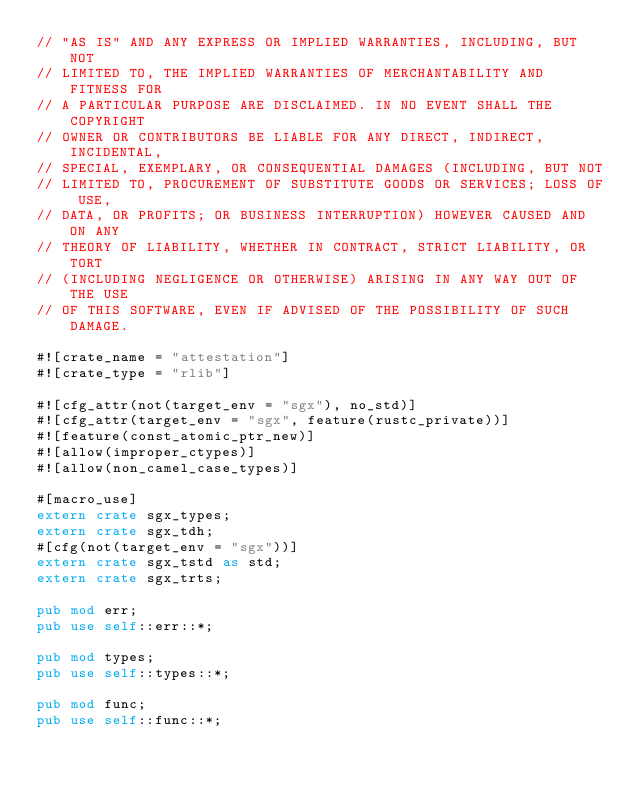<code> <loc_0><loc_0><loc_500><loc_500><_Rust_>// "AS IS" AND ANY EXPRESS OR IMPLIED WARRANTIES, INCLUDING, BUT NOT
// LIMITED TO, THE IMPLIED WARRANTIES OF MERCHANTABILITY AND FITNESS FOR
// A PARTICULAR PURPOSE ARE DISCLAIMED. IN NO EVENT SHALL THE COPYRIGHT
// OWNER OR CONTRIBUTORS BE LIABLE FOR ANY DIRECT, INDIRECT, INCIDENTAL,
// SPECIAL, EXEMPLARY, OR CONSEQUENTIAL DAMAGES (INCLUDING, BUT NOT
// LIMITED TO, PROCUREMENT OF SUBSTITUTE GOODS OR SERVICES; LOSS OF USE,
// DATA, OR PROFITS; OR BUSINESS INTERRUPTION) HOWEVER CAUSED AND ON ANY
// THEORY OF LIABILITY, WHETHER IN CONTRACT, STRICT LIABILITY, OR TORT
// (INCLUDING NEGLIGENCE OR OTHERWISE) ARISING IN ANY WAY OUT OF THE USE
// OF THIS SOFTWARE, EVEN IF ADVISED OF THE POSSIBILITY OF SUCH DAMAGE.

#![crate_name = "attestation"]
#![crate_type = "rlib"]

#![cfg_attr(not(target_env = "sgx"), no_std)]
#![cfg_attr(target_env = "sgx", feature(rustc_private))]
#![feature(const_atomic_ptr_new)]
#![allow(improper_ctypes)]
#![allow(non_camel_case_types)]

#[macro_use]
extern crate sgx_types;
extern crate sgx_tdh;
#[cfg(not(target_env = "sgx"))]
extern crate sgx_tstd as std;
extern crate sgx_trts;

pub mod err;
pub use self::err::*;

pub mod types;
pub use self::types::*;

pub mod func;
pub use self::func::*;</code> 